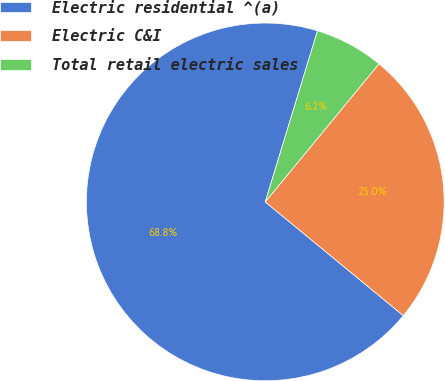<chart> <loc_0><loc_0><loc_500><loc_500><pie_chart><fcel>Electric residential ^(a)<fcel>Electric C&I<fcel>Total retail electric sales<nl><fcel>68.75%<fcel>25.0%<fcel>6.25%<nl></chart> 